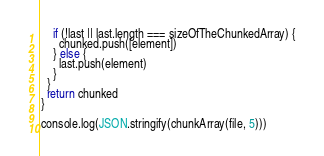<code> <loc_0><loc_0><loc_500><loc_500><_JavaScript_>
    if (!last || last.length === sizeOfTheChunkedArray) {
      chunked.push([element])
    } else {
      last.push(element)
    }
  }
  return chunked
}

console.log(JSON.stringify(chunkArray(file, 5)))
</code> 